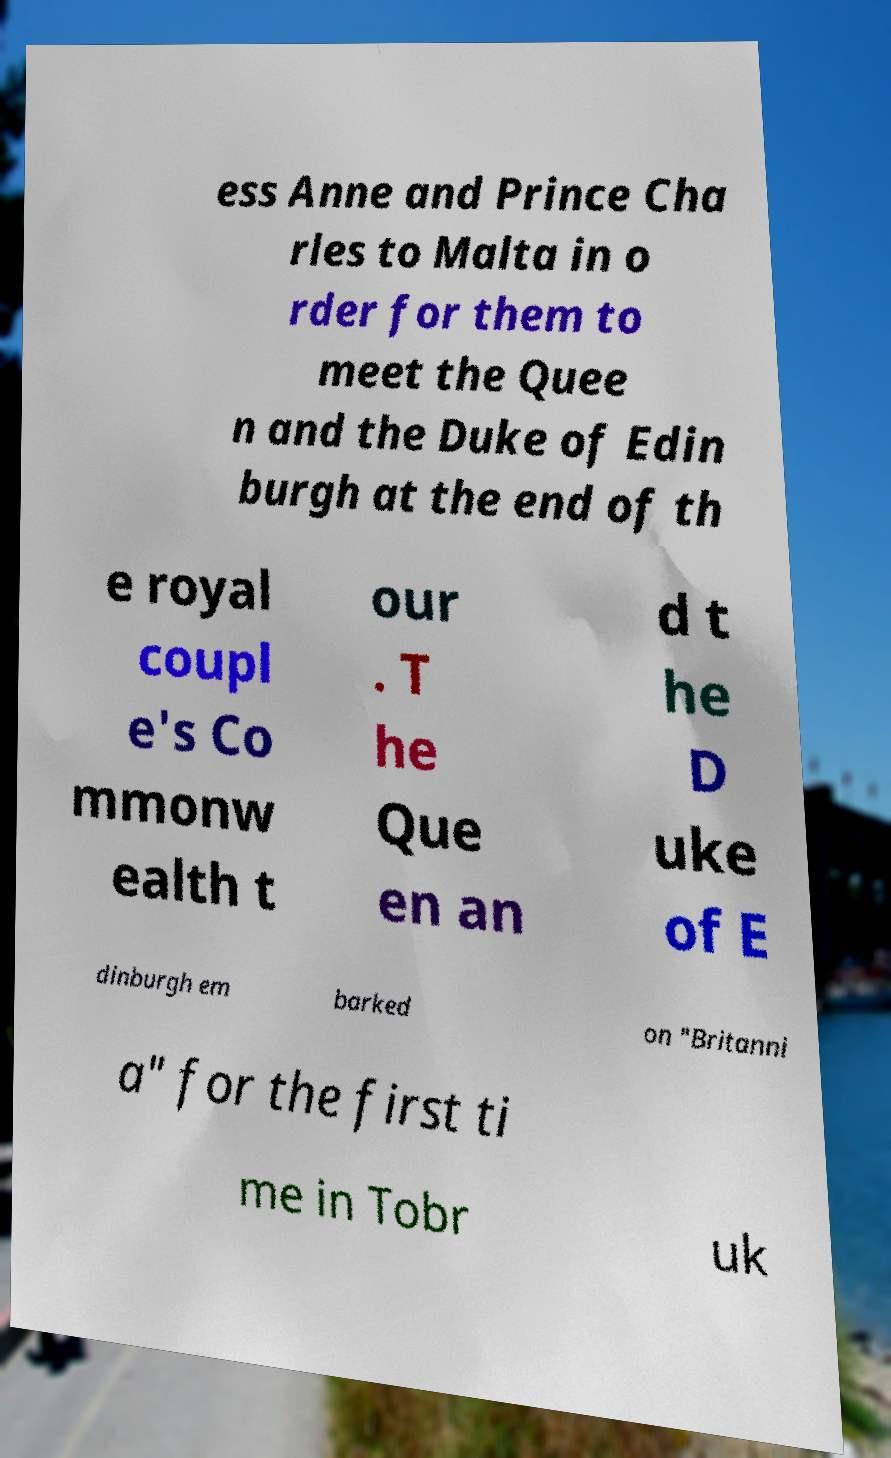Could you assist in decoding the text presented in this image and type it out clearly? ess Anne and Prince Cha rles to Malta in o rder for them to meet the Quee n and the Duke of Edin burgh at the end of th e royal coupl e's Co mmonw ealth t our . T he Que en an d t he D uke of E dinburgh em barked on "Britanni a" for the first ti me in Tobr uk 